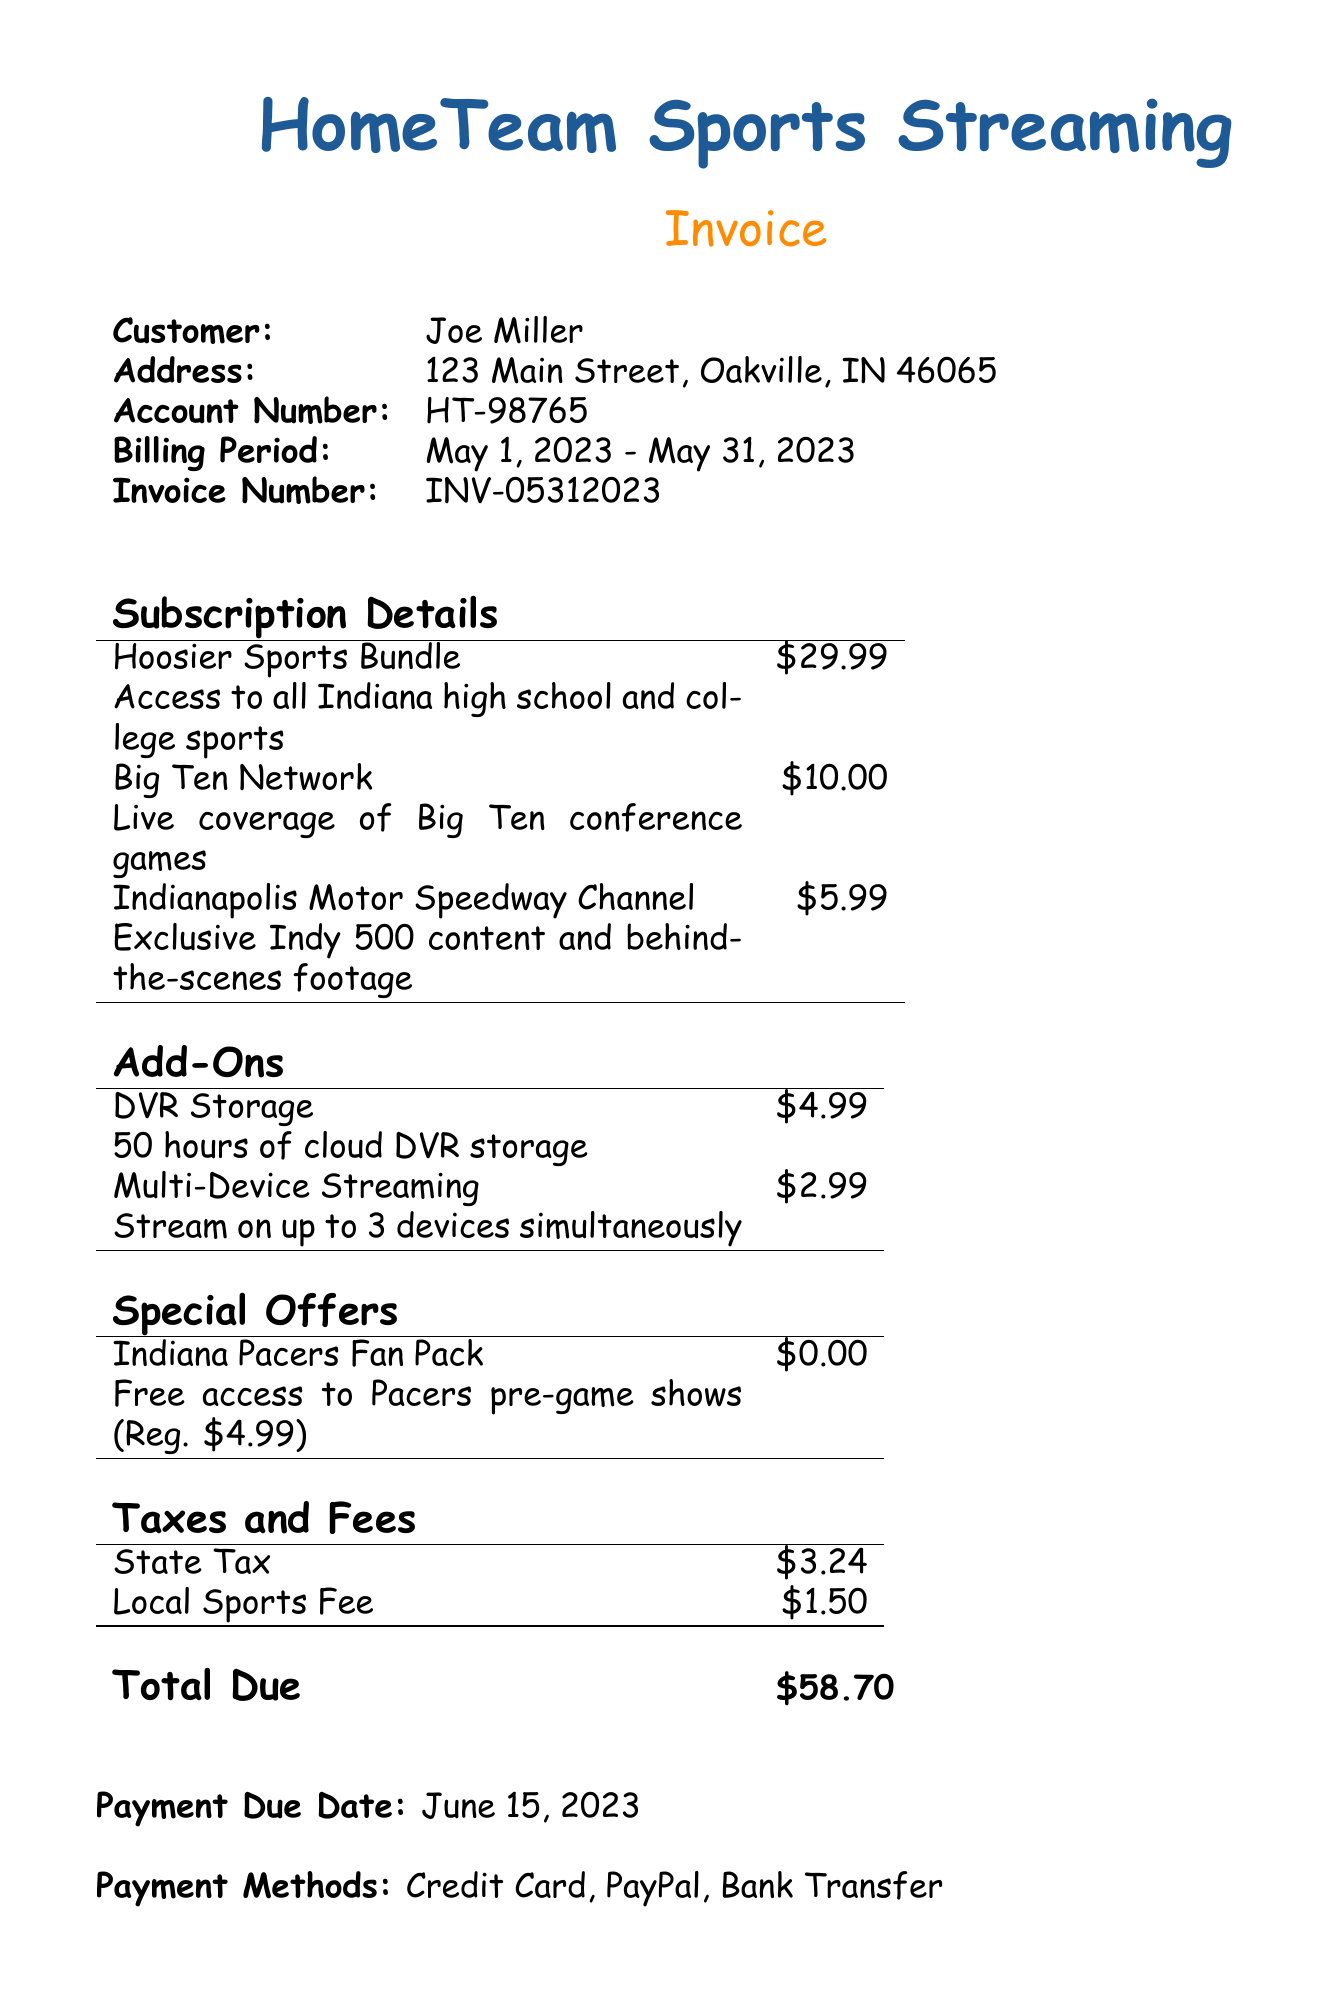What is the invoice number? The invoice number is clearly stated in the document, which is used for reference.
Answer: INV-05312023 What is the total due amount? The total due amount is prominently displayed on the document, highlighting the total payment required.
Answer: $58.70 Who is the customer? The document specifies the name of the customer to whom the invoice is addressed.
Answer: Joe Miller What is the billing period? The billing period indicates the time frame for which the services were billed, as noted in the document.
Answer: May 1, 2023 - May 31, 2023 How much is the state tax? The state tax is listed under the taxes and fees section of the document, indicating additional costs.
Answer: $3.24 What is included in the Hoosier Sports Bundle? The description of the package states what channels and coverage are provided for this subscription.
Answer: Access to all Indiana high school and college sports How many devices can stream simultaneously with Multi-Device Streaming? The add-on specifies the capability of streaming across multiple devices.
Answer: 3 devices What is the customer support phone number? The document provides contact information for customer assistance, which is essential for inquiries or issues.
Answer: 1-800-HOMETOWN What special note is mentioned about pausing the subscription? The document includes information about a new feature that allows modifications to the subscription.
Answer: You can now pause your subscription for up to 3 months per year 